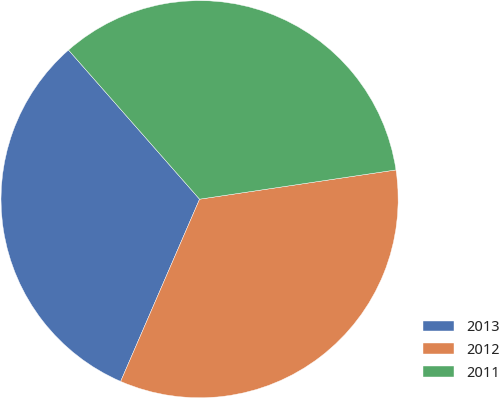Convert chart to OTSL. <chart><loc_0><loc_0><loc_500><loc_500><pie_chart><fcel>2013<fcel>2012<fcel>2011<nl><fcel>32.02%<fcel>33.86%<fcel>34.12%<nl></chart> 